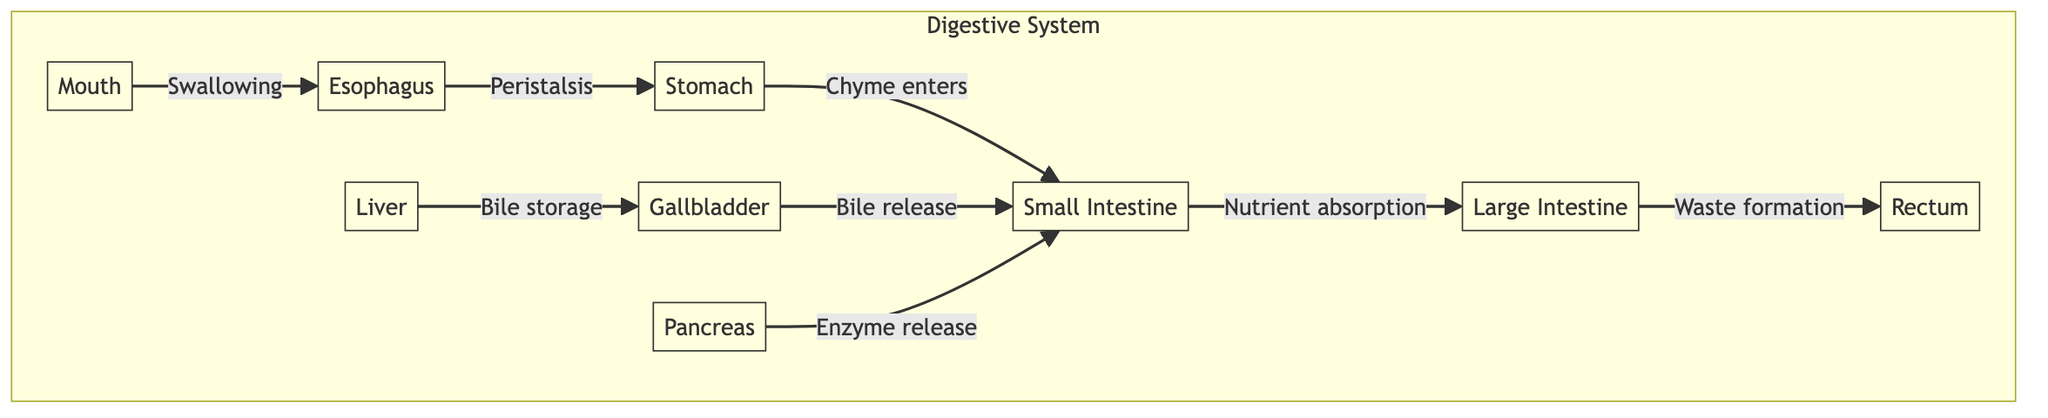What is the first organ in the digestive system? The first organ in the flowchart representing the digestive system is labeled "Mouth." It is positioned at the top and is the starting point of the digestive process.
Answer: Mouth How many major organs are involved in digestion according to the diagram? The diagram presents a total of six major organs that are involved in digestion, which are the mouth, esophagus, stomach, small intestine, large intestine, and rectum.
Answer: Six What process occurs between the stomach and small intestine? The diagram shows that the process occurring from the stomach to the small intestine is labeled "Chyme enters." This indicates that the contents from the stomach, known as chyme, move into the small intestine.
Answer: Chyme enters What organ is associated with bile storage in this diagram? According to the diagram, the organ associated with bile storage is labeled "Liver," which is connected to the gallbladder for this function.
Answer: Liver Which gland releases enzymes into the small intestine? The diagram identifies "Pancreas" as the gland responsible for releasing enzymes into the small intestine to aid in digestion.
Answer: Pancreas What is the relationship between the small intestine and the large intestine? The diagram illustrates that the small intestine leads to the large intestine with the process labeled "Waste formation," indicating a sequential flow of contents from digestion to waste.
Answer: Waste formation How does bile reach the small intestine? Based on the diagram, bile stored in the gallbladder is released into the small intestine, indicating a direct connection and flow from the gallbladder to the small intestine for digestion.
Answer: Bile release What is the final organ involved in the digestive system according to the diagram? The last organ depicted in the diagram of the digestive system is the "Rectum," which represents the end of the digestive tract.
Answer: Rectum 